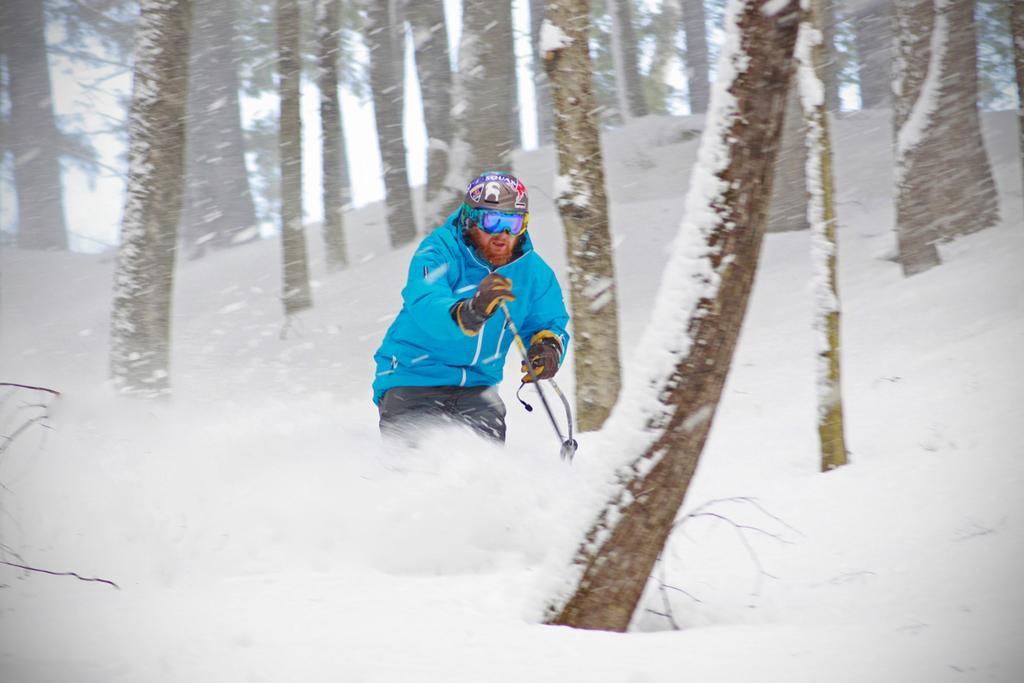Describe this image in one or two sentences. In this image I can see the person with blue and black color dress and the person is holding the sticks. I can see the person is on the snow. In the background I can see many trees and the sky. 